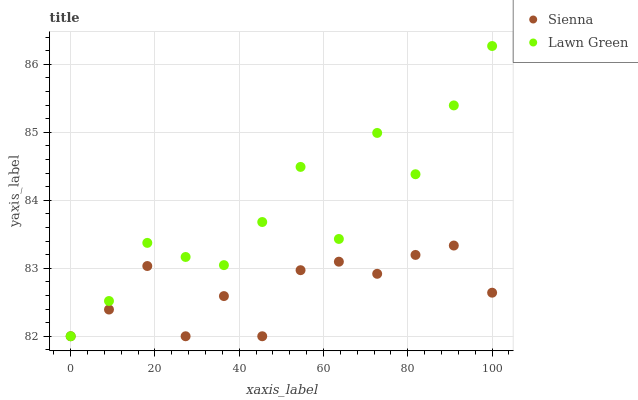Does Sienna have the minimum area under the curve?
Answer yes or no. Yes. Does Lawn Green have the maximum area under the curve?
Answer yes or no. Yes. Does Lawn Green have the minimum area under the curve?
Answer yes or no. No. Is Sienna the smoothest?
Answer yes or no. Yes. Is Lawn Green the roughest?
Answer yes or no. Yes. Is Lawn Green the smoothest?
Answer yes or no. No. Does Sienna have the lowest value?
Answer yes or no. Yes. Does Lawn Green have the highest value?
Answer yes or no. Yes. Does Lawn Green intersect Sienna?
Answer yes or no. Yes. Is Lawn Green less than Sienna?
Answer yes or no. No. Is Lawn Green greater than Sienna?
Answer yes or no. No. 